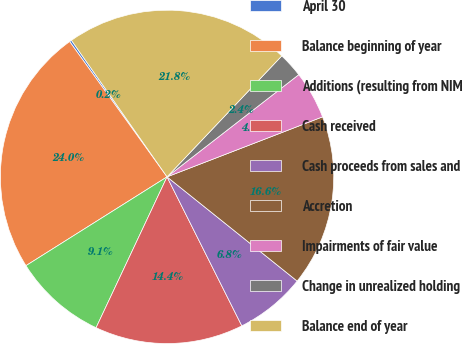Convert chart. <chart><loc_0><loc_0><loc_500><loc_500><pie_chart><fcel>April 30<fcel>Balance beginning of year<fcel>Additions (resulting from NIM<fcel>Cash received<fcel>Cash proceeds from sales and<fcel>Accretion<fcel>Impairments of fair value<fcel>Change in unrealized holding<fcel>Balance end of year<nl><fcel>0.21%<fcel>24.01%<fcel>9.06%<fcel>14.4%<fcel>6.85%<fcel>16.61%<fcel>4.64%<fcel>2.42%<fcel>21.8%<nl></chart> 